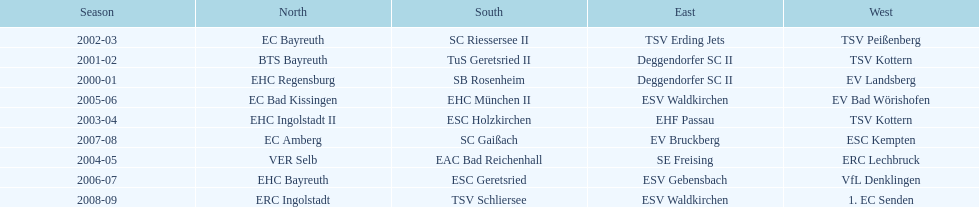Who won the south after esc geretsried did during the 2006-07 season? SC Gaißach. 